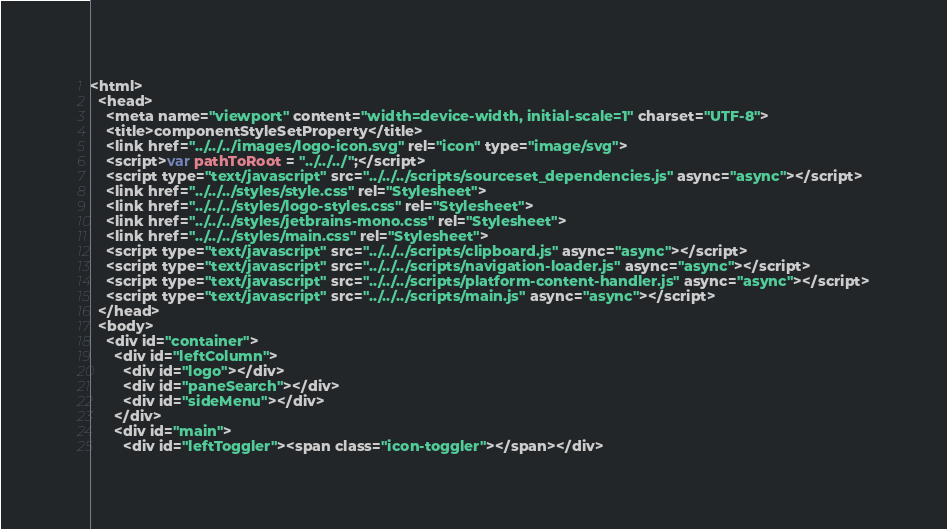Convert code to text. <code><loc_0><loc_0><loc_500><loc_500><_HTML_><html>
  <head>
    <meta name="viewport" content="width=device-width, initial-scale=1" charset="UTF-8">
    <title>componentStyleSetProperty</title>
    <link href="../../../images/logo-icon.svg" rel="icon" type="image/svg">
    <script>var pathToRoot = "../../../";</script>
    <script type="text/javascript" src="../../../scripts/sourceset_dependencies.js" async="async"></script>
    <link href="../../../styles/style.css" rel="Stylesheet">
    <link href="../../../styles/logo-styles.css" rel="Stylesheet">
    <link href="../../../styles/jetbrains-mono.css" rel="Stylesheet">
    <link href="../../../styles/main.css" rel="Stylesheet">
    <script type="text/javascript" src="../../../scripts/clipboard.js" async="async"></script>
    <script type="text/javascript" src="../../../scripts/navigation-loader.js" async="async"></script>
    <script type="text/javascript" src="../../../scripts/platform-content-handler.js" async="async"></script>
    <script type="text/javascript" src="../../../scripts/main.js" async="async"></script>
  </head>
  <body>
    <div id="container">
      <div id="leftColumn">
        <div id="logo"></div>
        <div id="paneSearch"></div>
        <div id="sideMenu"></div>
      </div>
      <div id="main">
        <div id="leftToggler"><span class="icon-toggler"></span></div></code> 